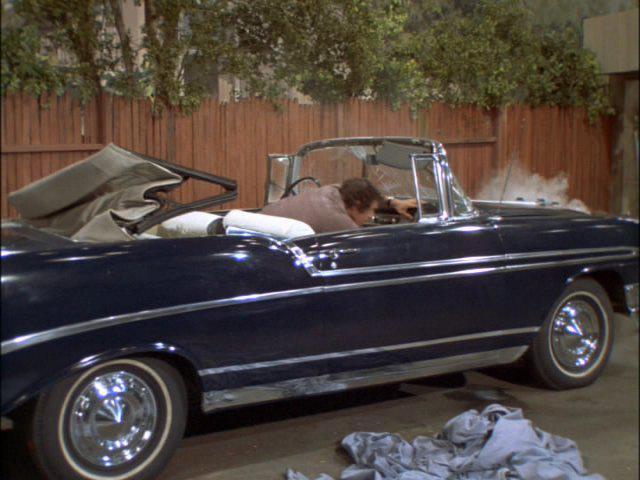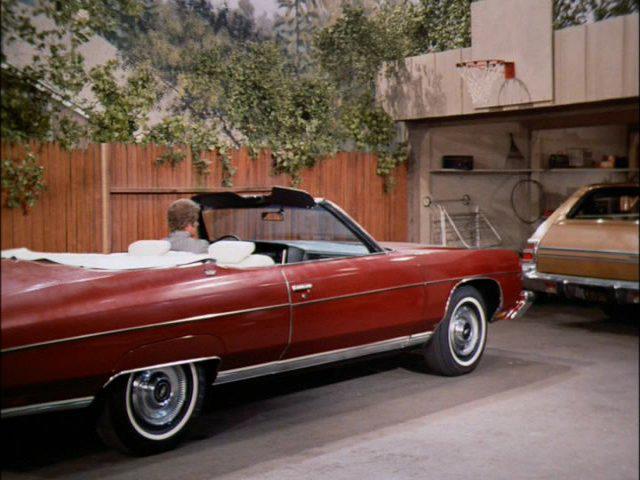The first image is the image on the left, the second image is the image on the right. Analyze the images presented: Is the assertion "Two cars have convertible tops and have small wing windows beside the windshield." valid? Answer yes or no. No. The first image is the image on the left, the second image is the image on the right. For the images displayed, is the sentence "An image shows at least two people in a blue convertible with the top down, next to a privacy fence." factually correct? Answer yes or no. No. 